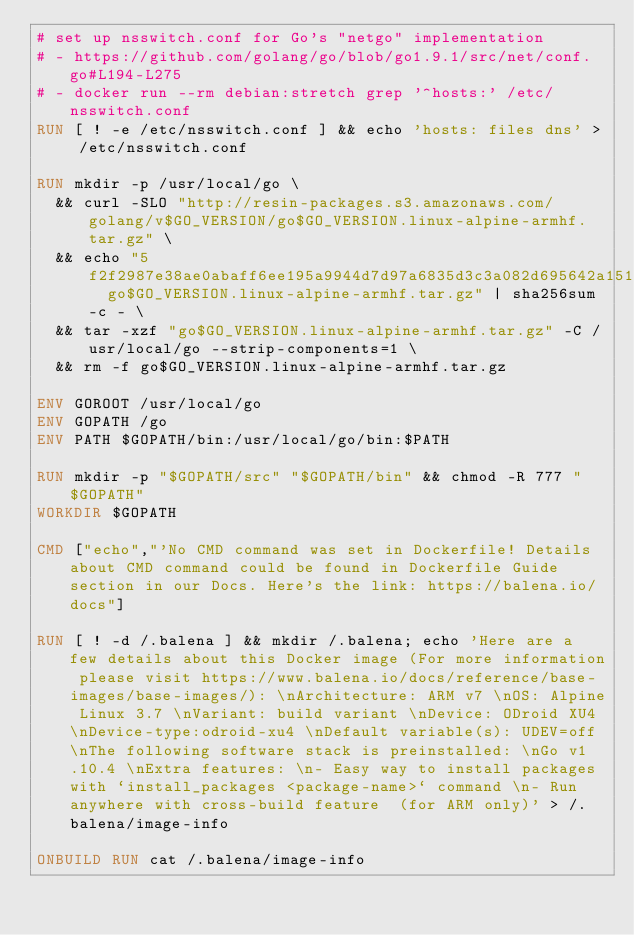Convert code to text. <code><loc_0><loc_0><loc_500><loc_500><_Dockerfile_># set up nsswitch.conf for Go's "netgo" implementation
# - https://github.com/golang/go/blob/go1.9.1/src/net/conf.go#L194-L275
# - docker run --rm debian:stretch grep '^hosts:' /etc/nsswitch.conf
RUN [ ! -e /etc/nsswitch.conf ] && echo 'hosts: files dns' > /etc/nsswitch.conf

RUN mkdir -p /usr/local/go \
	&& curl -SLO "http://resin-packages.s3.amazonaws.com/golang/v$GO_VERSION/go$GO_VERSION.linux-alpine-armhf.tar.gz" \
	&& echo "5f2f2987e38ae0abaff6ee195a9944d7d97a6835d3c3a082d695642a151f8ce3  go$GO_VERSION.linux-alpine-armhf.tar.gz" | sha256sum -c - \
	&& tar -xzf "go$GO_VERSION.linux-alpine-armhf.tar.gz" -C /usr/local/go --strip-components=1 \
	&& rm -f go$GO_VERSION.linux-alpine-armhf.tar.gz

ENV GOROOT /usr/local/go
ENV GOPATH /go
ENV PATH $GOPATH/bin:/usr/local/go/bin:$PATH

RUN mkdir -p "$GOPATH/src" "$GOPATH/bin" && chmod -R 777 "$GOPATH"
WORKDIR $GOPATH

CMD ["echo","'No CMD command was set in Dockerfile! Details about CMD command could be found in Dockerfile Guide section in our Docs. Here's the link: https://balena.io/docs"]

RUN [ ! -d /.balena ] && mkdir /.balena; echo 'Here are a few details about this Docker image (For more information please visit https://www.balena.io/docs/reference/base-images/base-images/): \nArchitecture: ARM v7 \nOS: Alpine Linux 3.7 \nVariant: build variant \nDevice: ODroid XU4 \nDevice-type:odroid-xu4 \nDefault variable(s): UDEV=off \nThe following software stack is preinstalled: \nGo v1.10.4 \nExtra features: \n- Easy way to install packages with `install_packages <package-name>` command \n- Run anywhere with cross-build feature  (for ARM only)' > /.balena/image-info

ONBUILD RUN cat /.balena/image-info</code> 